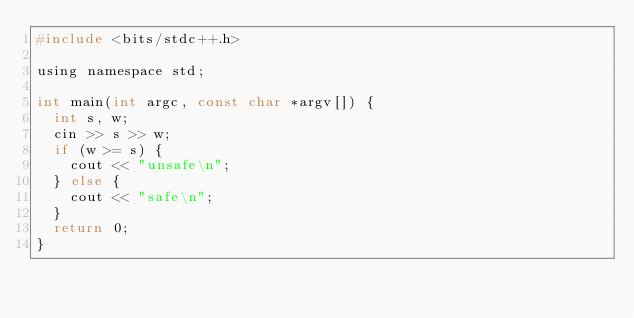Convert code to text. <code><loc_0><loc_0><loc_500><loc_500><_C_>#include <bits/stdc++.h>

using namespace std;

int main(int argc, const char *argv[]) {
  int s, w;
  cin >> s >> w;
  if (w >= s) {
    cout << "unsafe\n";
  } else {
    cout << "safe\n";
  }
  return 0;
}</code> 